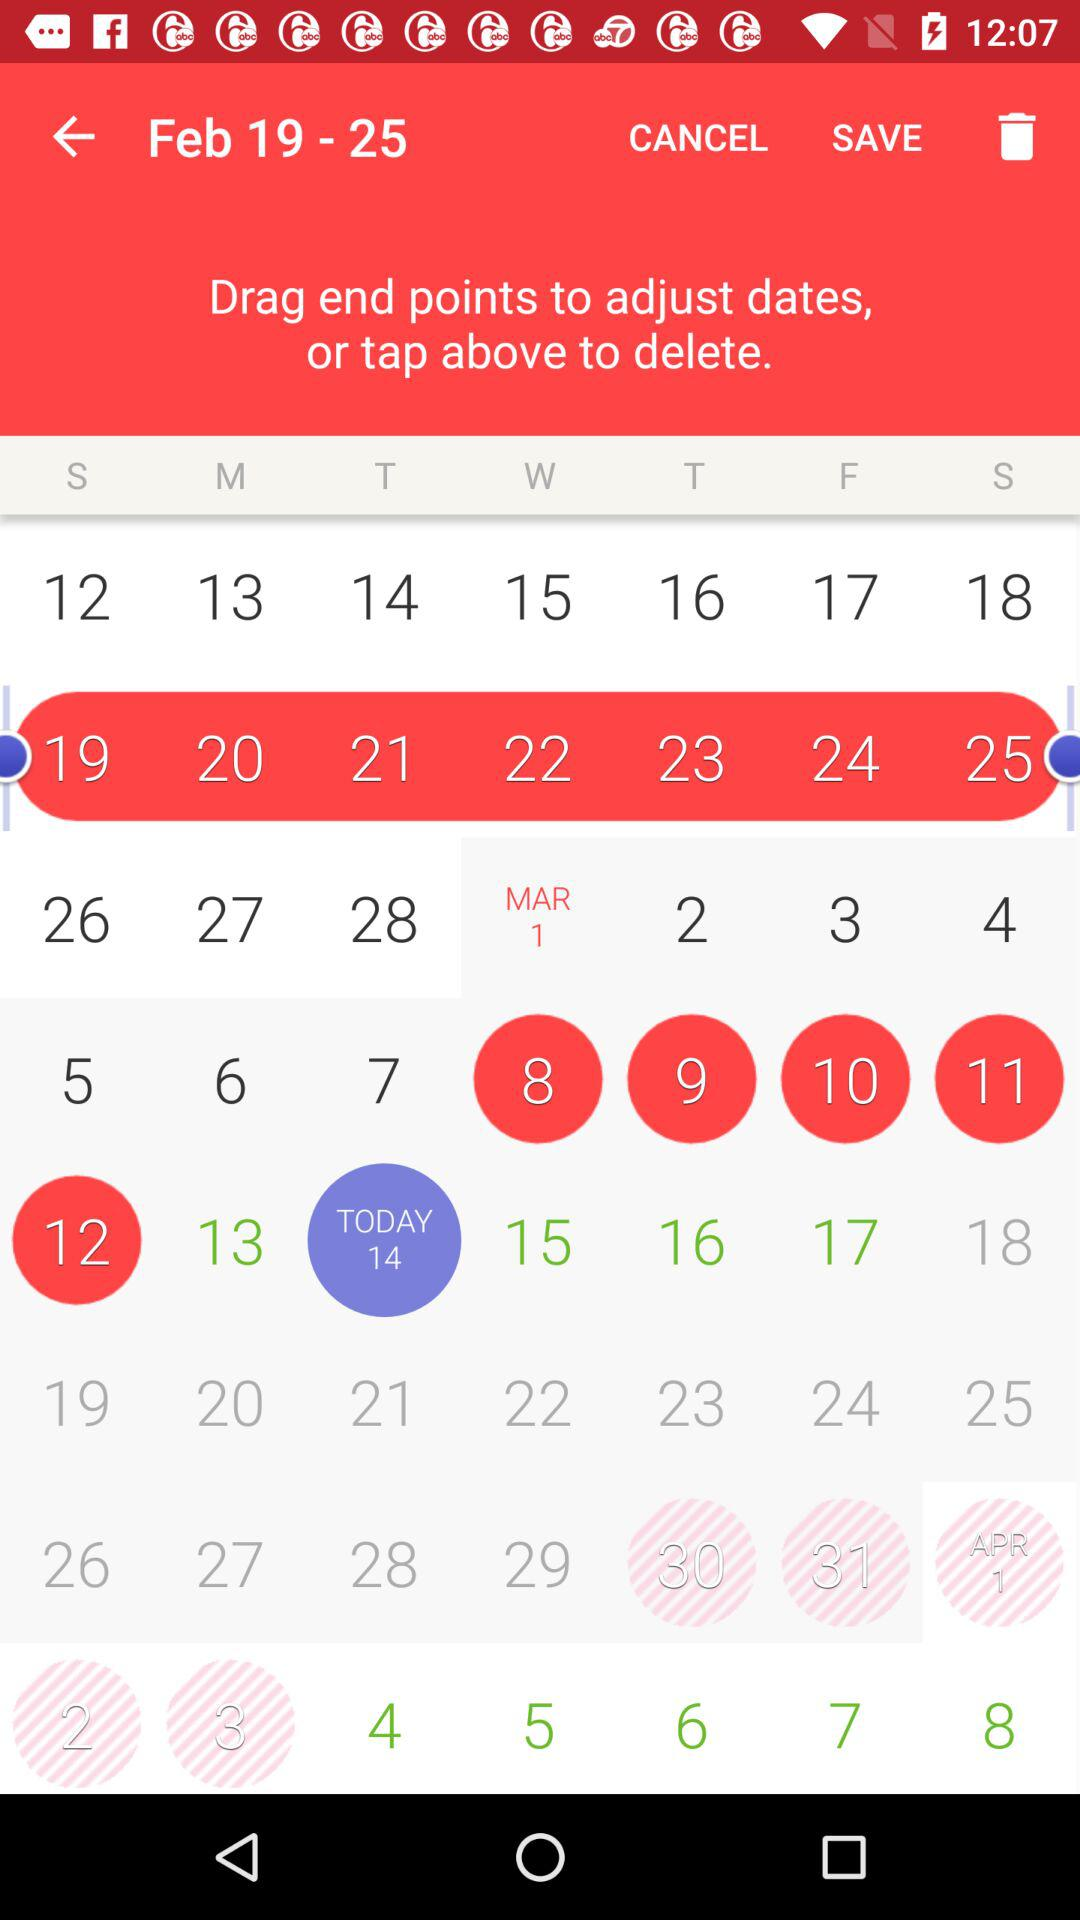What is the selected date range? The selected date range is from February 19 to February 25. 